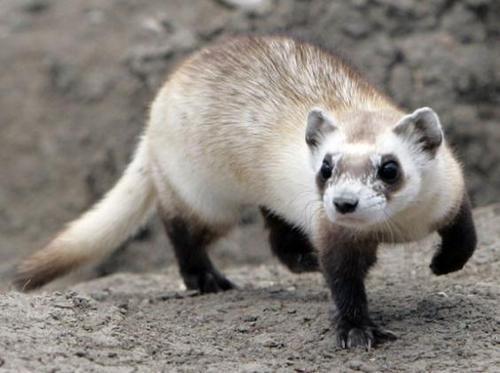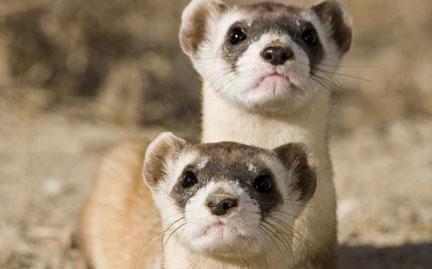The first image is the image on the left, the second image is the image on the right. Evaluate the accuracy of this statement regarding the images: "The left animal is mostly underground, the right animal is entirely above ground.". Is it true? Answer yes or no. No. 